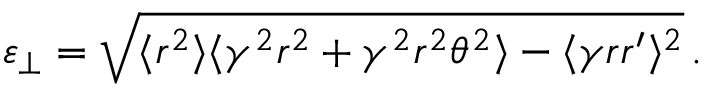<formula> <loc_0><loc_0><loc_500><loc_500>\varepsilon _ { \perp } = \sqrt { \langle r ^ { 2 } \rangle \langle \gamma ^ { 2 } r ^ { 2 } + \gamma ^ { 2 } r ^ { 2 } \theta ^ { 2 } \rangle - \langle \gamma r r ^ { \prime } \rangle ^ { 2 } } \, .</formula> 